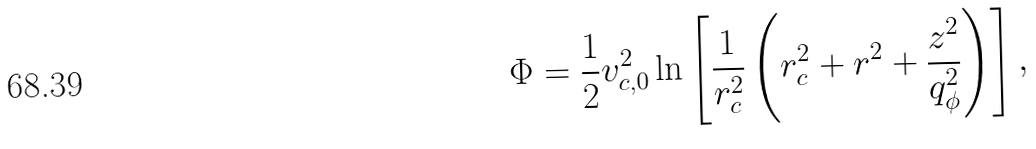<formula> <loc_0><loc_0><loc_500><loc_500>\Phi = \frac { 1 } { 2 } v _ { c , 0 } ^ { 2 } \ln \left [ \frac { 1 } { r _ { c } ^ { 2 } } \left ( r _ { c } ^ { 2 } + r ^ { 2 } + \frac { z ^ { 2 } } { q _ { \phi } ^ { 2 } } \right ) \right ] ,</formula> 